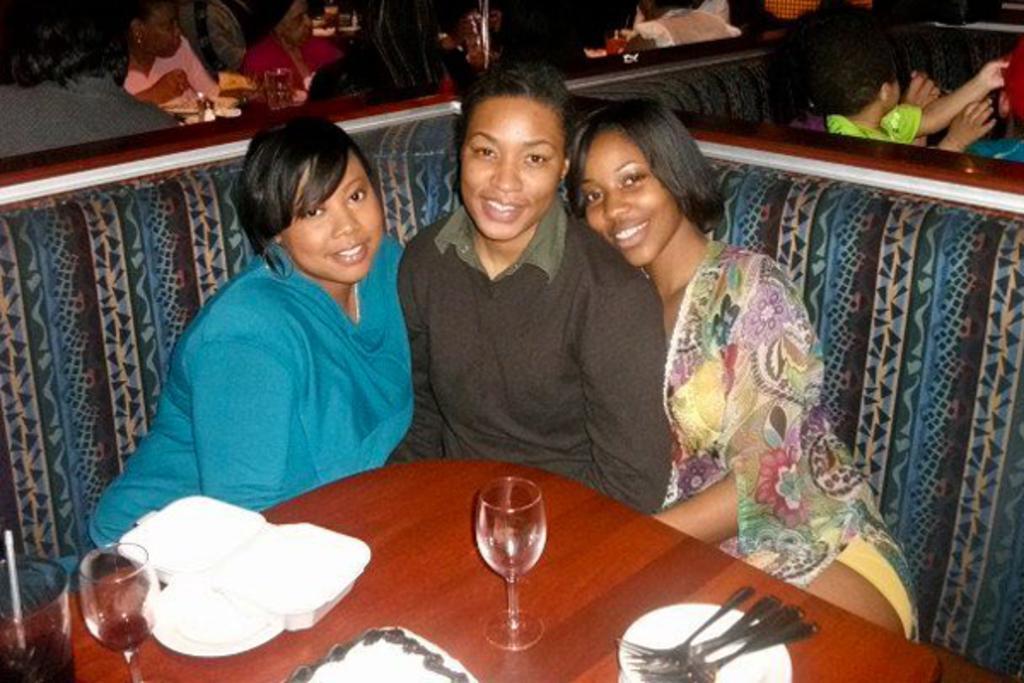Can you describe this image briefly? In this image three ladies are sitting on sofa. They are smiling. In front of them on a table there are glasses, spoons, plates. In the background few other people are sitting and having food. 